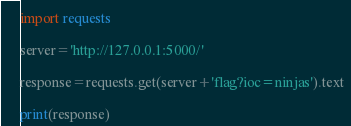Convert code to text. <code><loc_0><loc_0><loc_500><loc_500><_Python_>import requests

server='http://127.0.0.1:5000/'

response=requests.get(server+'flag?ioc=ninjas').text

print(response)

</code> 